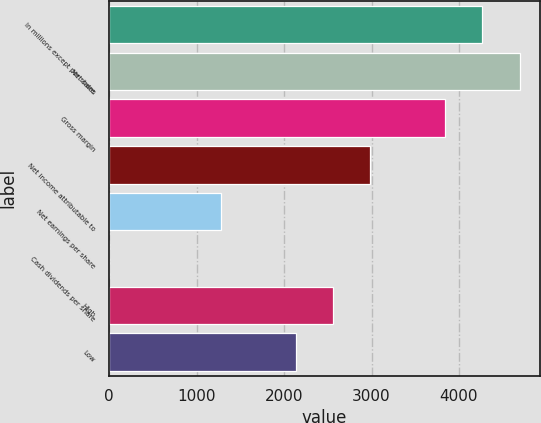Convert chart. <chart><loc_0><loc_0><loc_500><loc_500><bar_chart><fcel>In millions except per share<fcel>Net sales<fcel>Gross margin<fcel>Net income attributable to<fcel>Net earnings per share<fcel>Cash dividends per share<fcel>High<fcel>Low<nl><fcel>4266.02<fcel>4692.56<fcel>3839.48<fcel>2986.4<fcel>1280.24<fcel>0.62<fcel>2559.86<fcel>2133.32<nl></chart> 